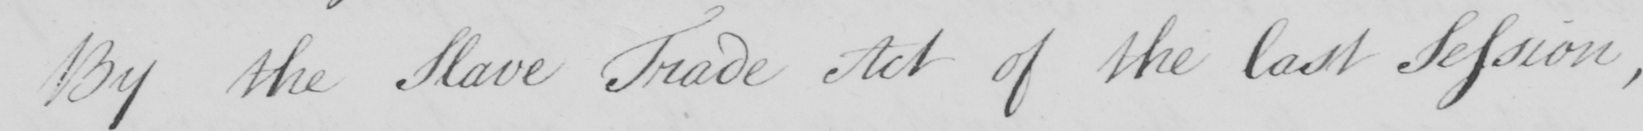Please provide the text content of this handwritten line. By the Slave Trade Act of the last Session , 